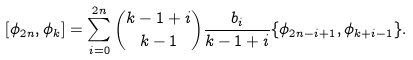<formula> <loc_0><loc_0><loc_500><loc_500>[ \phi _ { 2 n } , \phi _ { k } ] = \sum _ { i = 0 } ^ { 2 n } \binom { k - 1 + i } { k - 1 } \frac { b _ { i } } { k - 1 + i } \{ \phi _ { 2 n - i + 1 } , \phi _ { k + i - 1 } \} .</formula> 